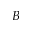Convert formula to latex. <formula><loc_0><loc_0><loc_500><loc_500>B</formula> 